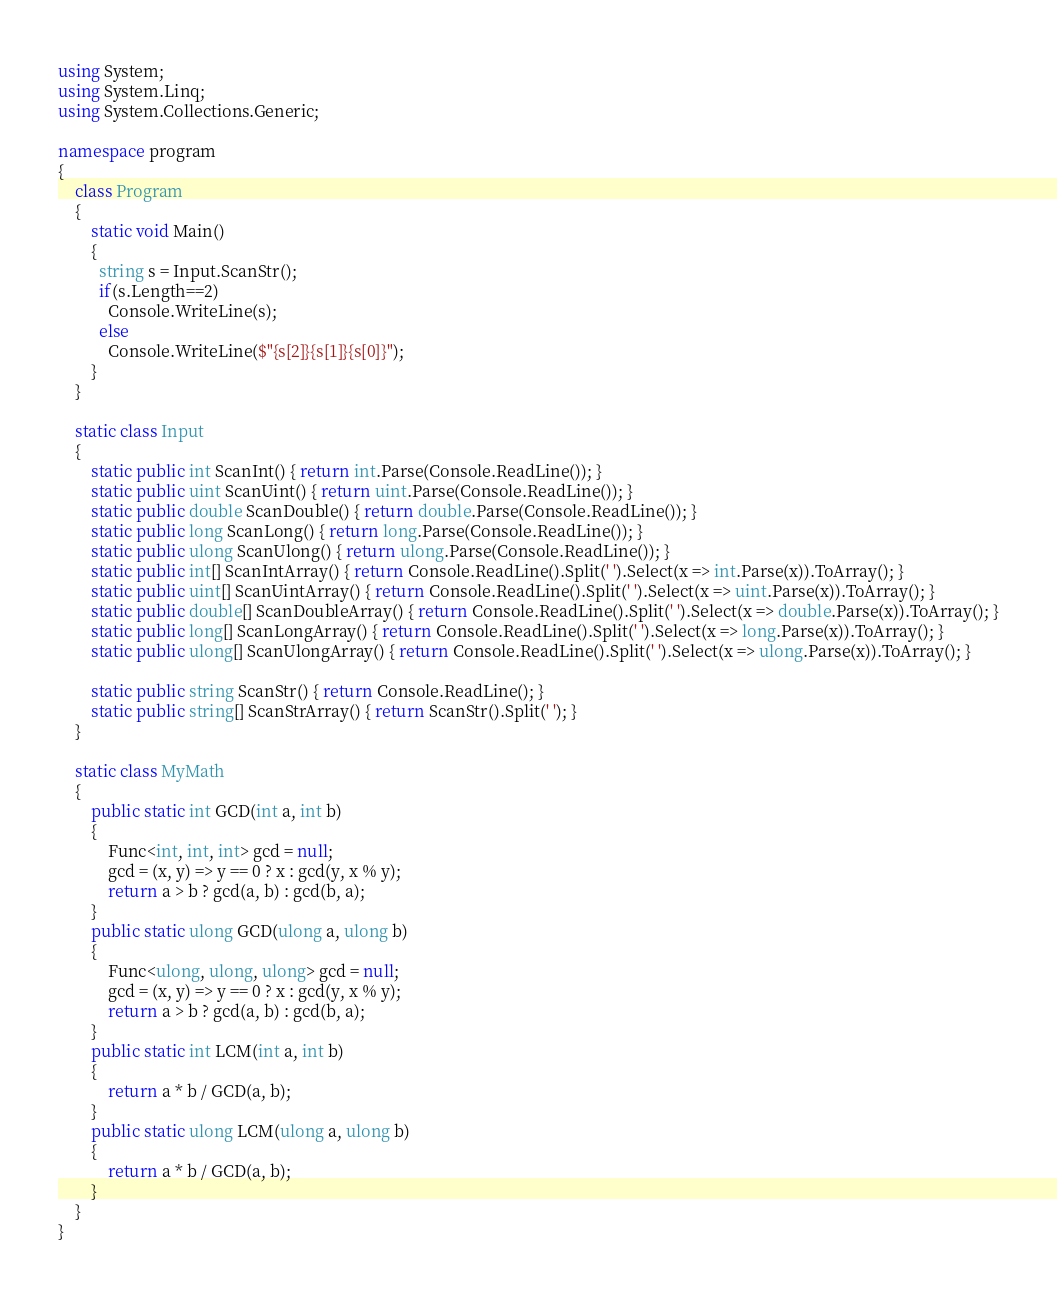<code> <loc_0><loc_0><loc_500><loc_500><_C#_>using System;
using System.Linq;
using System.Collections.Generic;

namespace program
{
    class Program
    {
        static void Main()
        {
          string s = Input.ScanStr();
          if(s.Length==2)
            Console.WriteLine(s);
          else
            Console.WriteLine($"{s[2]}{s[1]}{s[0]}");
        }
    }

    static class Input
    {
        static public int ScanInt() { return int.Parse(Console.ReadLine()); }
        static public uint ScanUint() { return uint.Parse(Console.ReadLine()); }
        static public double ScanDouble() { return double.Parse(Console.ReadLine()); }
        static public long ScanLong() { return long.Parse(Console.ReadLine()); }
        static public ulong ScanUlong() { return ulong.Parse(Console.ReadLine()); }
        static public int[] ScanIntArray() { return Console.ReadLine().Split(' ').Select(x => int.Parse(x)).ToArray(); }
        static public uint[] ScanUintArray() { return Console.ReadLine().Split(' ').Select(x => uint.Parse(x)).ToArray(); }
        static public double[] ScanDoubleArray() { return Console.ReadLine().Split(' ').Select(x => double.Parse(x)).ToArray(); }
        static public long[] ScanLongArray() { return Console.ReadLine().Split(' ').Select(x => long.Parse(x)).ToArray(); }
        static public ulong[] ScanUlongArray() { return Console.ReadLine().Split(' ').Select(x => ulong.Parse(x)).ToArray(); }

        static public string ScanStr() { return Console.ReadLine(); }
        static public string[] ScanStrArray() { return ScanStr().Split(' '); }
    }

    static class MyMath
    {
        public static int GCD(int a, int b)
        {
            Func<int, int, int> gcd = null;
            gcd = (x, y) => y == 0 ? x : gcd(y, x % y);
            return a > b ? gcd(a, b) : gcd(b, a);
        }
        public static ulong GCD(ulong a, ulong b)
        {
            Func<ulong, ulong, ulong> gcd = null;
            gcd = (x, y) => y == 0 ? x : gcd(y, x % y);
            return a > b ? gcd(a, b) : gcd(b, a);
        }
        public static int LCM(int a, int b)
        {
            return a * b / GCD(a, b);
        }
        public static ulong LCM(ulong a, ulong b)
        {
            return a * b / GCD(a, b);
        }
    }
}
</code> 